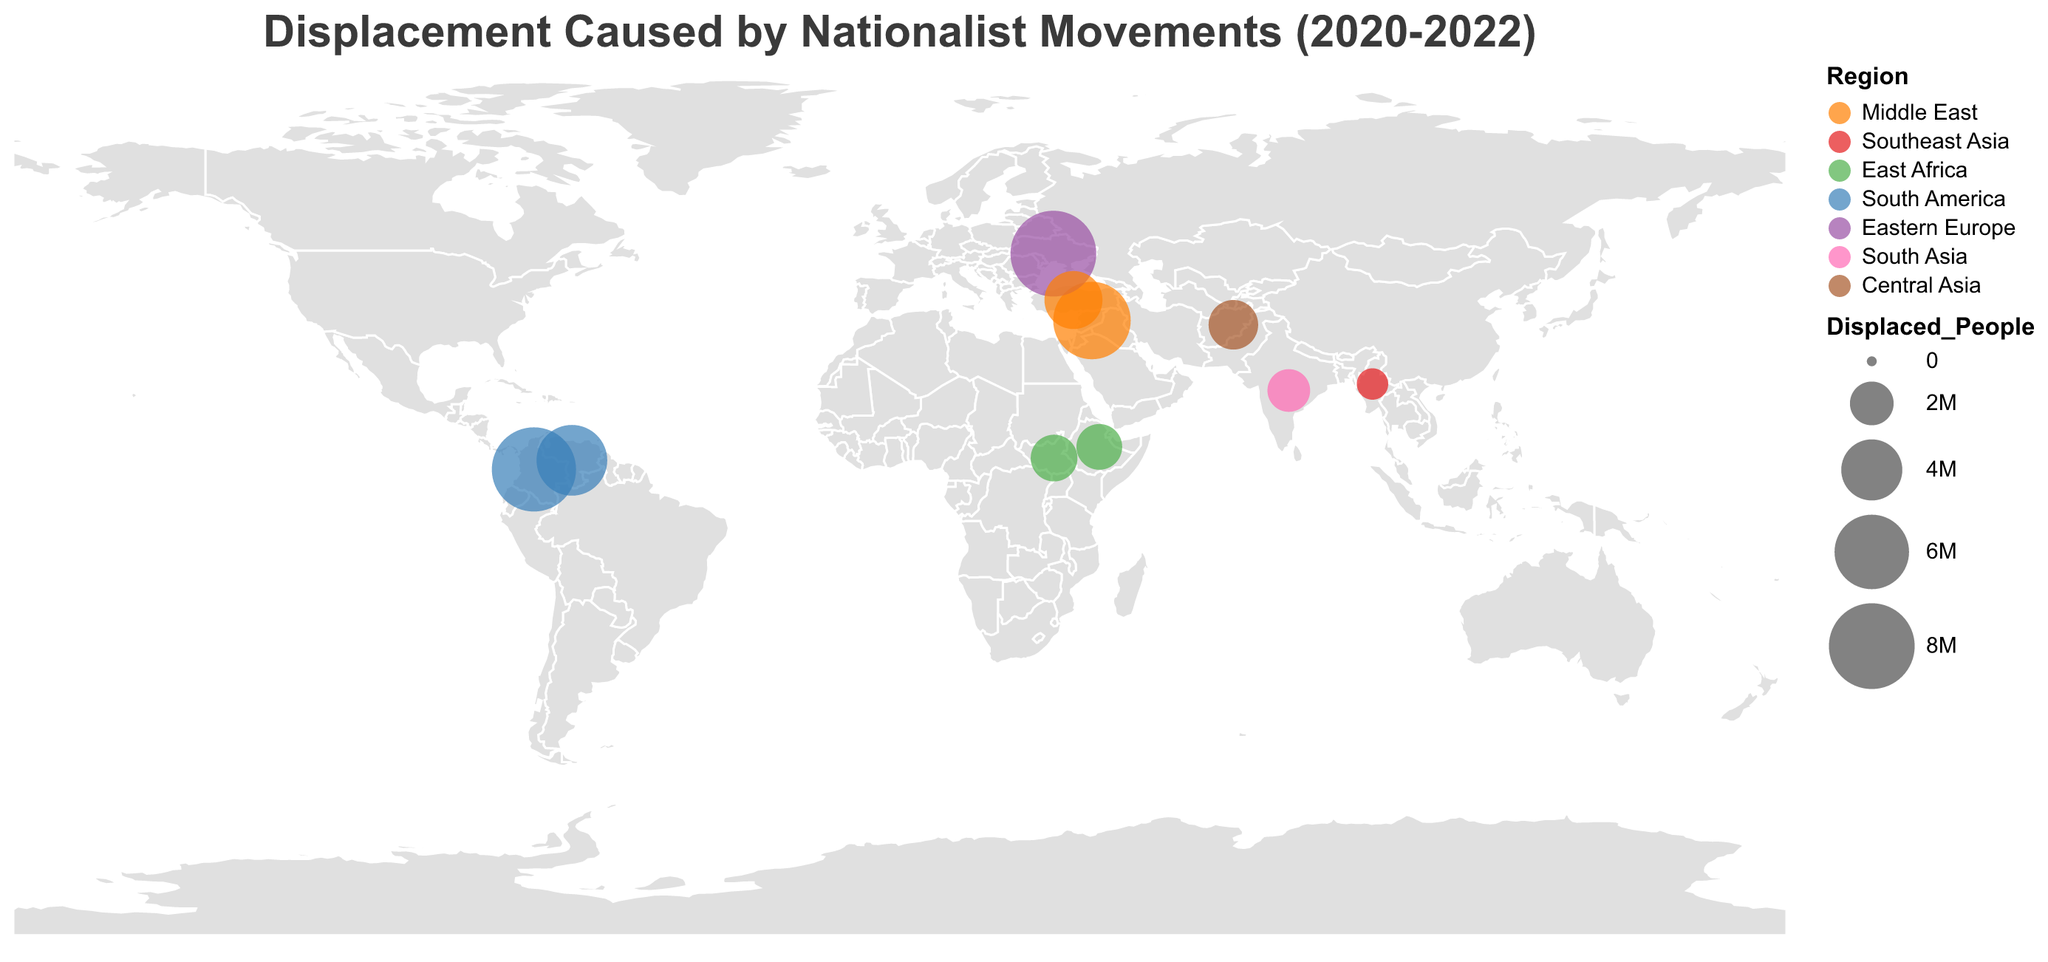What is the title of the plot? The title is usually located at the top of the plot and describes what the plot is about. In this case, it mentions displacement caused by nationalist movements between 2020-2022.
Answer: Displacement Caused by Nationalist Movements (2020-2022) In which country has the largest number of people been displaced? By observing the circles on the plot and their sizes, the largest circle represents the highest number of displaced people. The circle with the largest size is corresponding to Ukraine.
Answer: Ukraine What region is represented by the color green? The legend in the plot will show the color coding for different regions. Green corresponds to East Africa.
Answer: East Africa Compare the displacement in Syria and Myanmar; which country has more displaced people? By observing the size of the circles for both Syria and Myanmar, Syria has a larger circle, indicating more displaced people.
Answer: Syria What is the total number of people displaced in South America? By summing the number of displaced people in South American countries (Venezuela and Colombia), which are 5,400,000 and 7,700,000 respectively, we get a total of 13,100,000.
Answer: 13,100,000 Which country in the Middle East has the highest number of displaced people? By comparing the circles in the Middle East region, the largest circle corresponds to Syria.
Answer: Syria List all regions with at least one country experiencing displacement due to nationalist movements between 2020-2022. By observing the plot and its legend, the regions with circles indicating displacement are Middle East, Southeast Asia, East Africa, South America, Eastern Europe, South Asia, and Central Asia.
Answer: Middle East, Southeast Asia, East Africa, South America, Eastern Europe, South Asia, Central Asia Which nationalist movement caused the displacement in Ethiopia? By referring to the tooltip or data points on the map corresponding to Ethiopia, the nationalist movement is indicated as the Tigray People's Liberation Front.
Answer: Tigray People's Liberation Front How many countries depicted are in the Middle East? By referring to the legend and observing the plot, Syria and Turkey are the countries in the Middle East.
Answer: 2 Which country had displacement due to the Taliban Movement, and how many people were displaced? By referring to the tooltip or data points on the map, Afghanistan experienced displacement due to the Taliban Movement with 2,600,000 people displaced.
Answer: Afghanistan, 2,600,000 